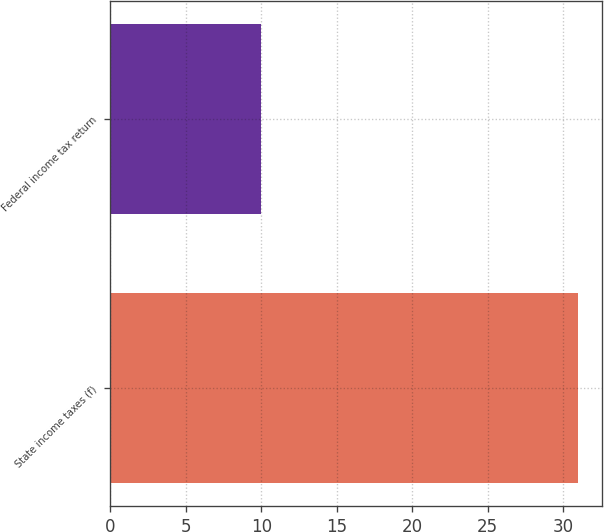Convert chart. <chart><loc_0><loc_0><loc_500><loc_500><bar_chart><fcel>State income taxes (f)<fcel>Federal income tax return<nl><fcel>31<fcel>10<nl></chart> 